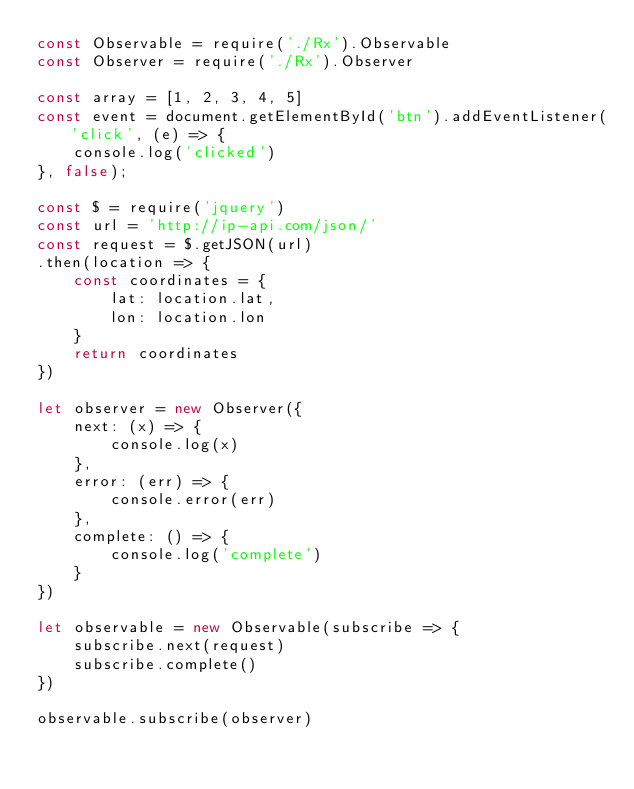Convert code to text. <code><loc_0><loc_0><loc_500><loc_500><_JavaScript_>const Observable = require('./Rx').Observable
const Observer = require('./Rx').Observer

const array = [1, 2, 3, 4, 5]
const event = document.getElementById('btn').addEventListener('click', (e) => {
    console.log('clicked')
}, false);

const $ = require('jquery')
const url = 'http://ip-api.com/json/'
const request = $.getJSON(url)
.then(location => {
    const coordinates = {
        lat: location.lat,
        lon: location.lon
    }
    return coordinates
})

let observer = new Observer({
    next: (x) => {
        console.log(x)
    },
    error: (err) => {
        console.error(err)
    },
    complete: () => {
        console.log('complete')
    }
})

let observable = new Observable(subscribe => {
    subscribe.next(request)
    subscribe.complete()
})

observable.subscribe(observer)</code> 